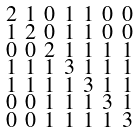Convert formula to latex. <formula><loc_0><loc_0><loc_500><loc_500>\begin{smallmatrix} 2 & 1 & 0 & 1 & 1 & 0 & 0 \\ 1 & 2 & 0 & 1 & 1 & 0 & 0 \\ 0 & 0 & 2 & 1 & 1 & 1 & 1 \\ 1 & 1 & 1 & 3 & 1 & 1 & 1 \\ 1 & 1 & 1 & 1 & 3 & 1 & 1 \\ 0 & 0 & 1 & 1 & 1 & 3 & 1 \\ 0 & 0 & 1 & 1 & 1 & 1 & 3 \end{smallmatrix}</formula> 